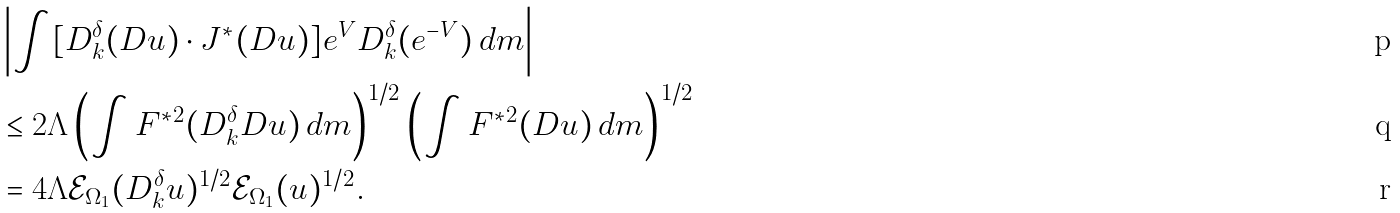<formula> <loc_0><loc_0><loc_500><loc_500>& \left | \int [ D _ { k } ^ { \delta } ( D u ) \cdot J ^ { * } ( D u ) ] e ^ { V } D _ { k } ^ { \delta } ( e ^ { - V } ) \, d m \right | \\ & \leq 2 \Lambda \left ( \int F ^ { * 2 } ( D _ { k } ^ { \delta } D u ) \, d m \right ) ^ { 1 / 2 } \left ( \int F ^ { * 2 } ( D u ) \, d m \right ) ^ { 1 / 2 } \\ & = 4 \Lambda \mathcal { E } _ { \Omega _ { 1 } } ( D _ { k } ^ { \delta } u ) ^ { 1 / 2 } \mathcal { E } _ { \Omega _ { 1 } } ( u ) ^ { 1 / 2 } .</formula> 